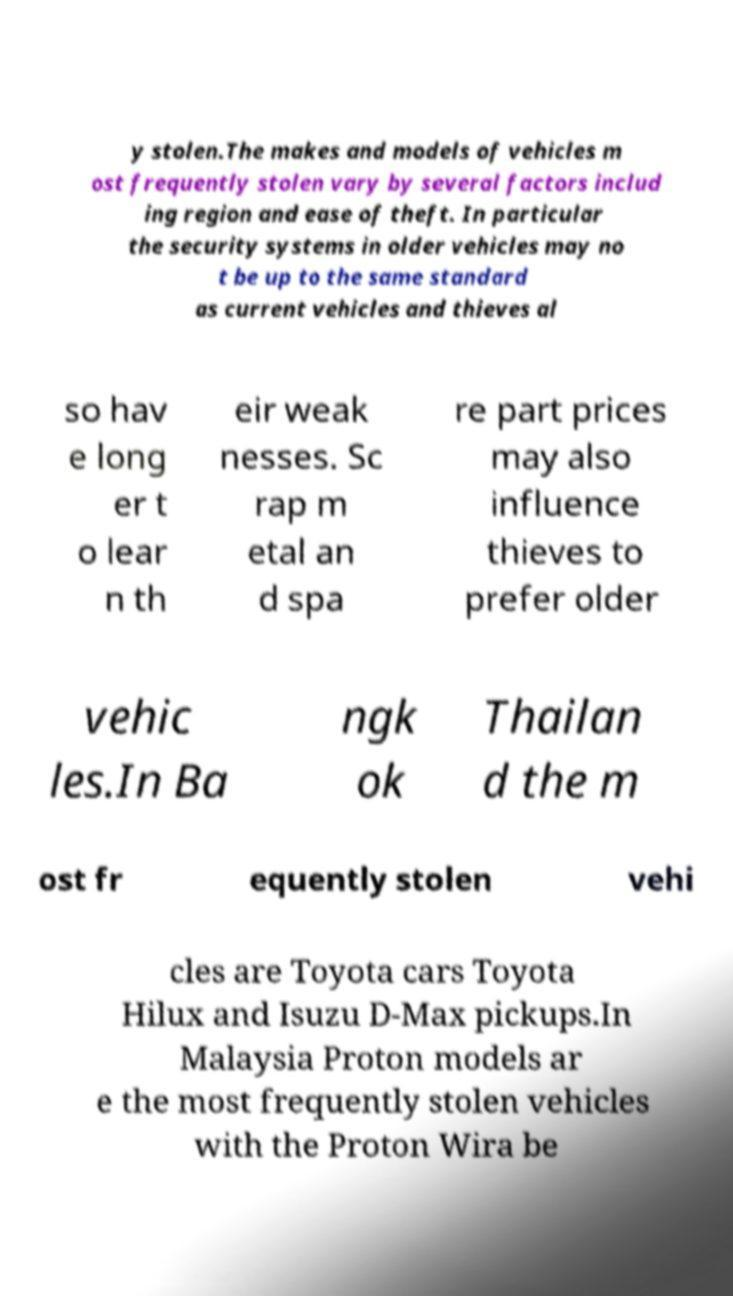There's text embedded in this image that I need extracted. Can you transcribe it verbatim? y stolen.The makes and models of vehicles m ost frequently stolen vary by several factors includ ing region and ease of theft. In particular the security systems in older vehicles may no t be up to the same standard as current vehicles and thieves al so hav e long er t o lear n th eir weak nesses. Sc rap m etal an d spa re part prices may also influence thieves to prefer older vehic les.In Ba ngk ok Thailan d the m ost fr equently stolen vehi cles are Toyota cars Toyota Hilux and Isuzu D-Max pickups.In Malaysia Proton models ar e the most frequently stolen vehicles with the Proton Wira be 